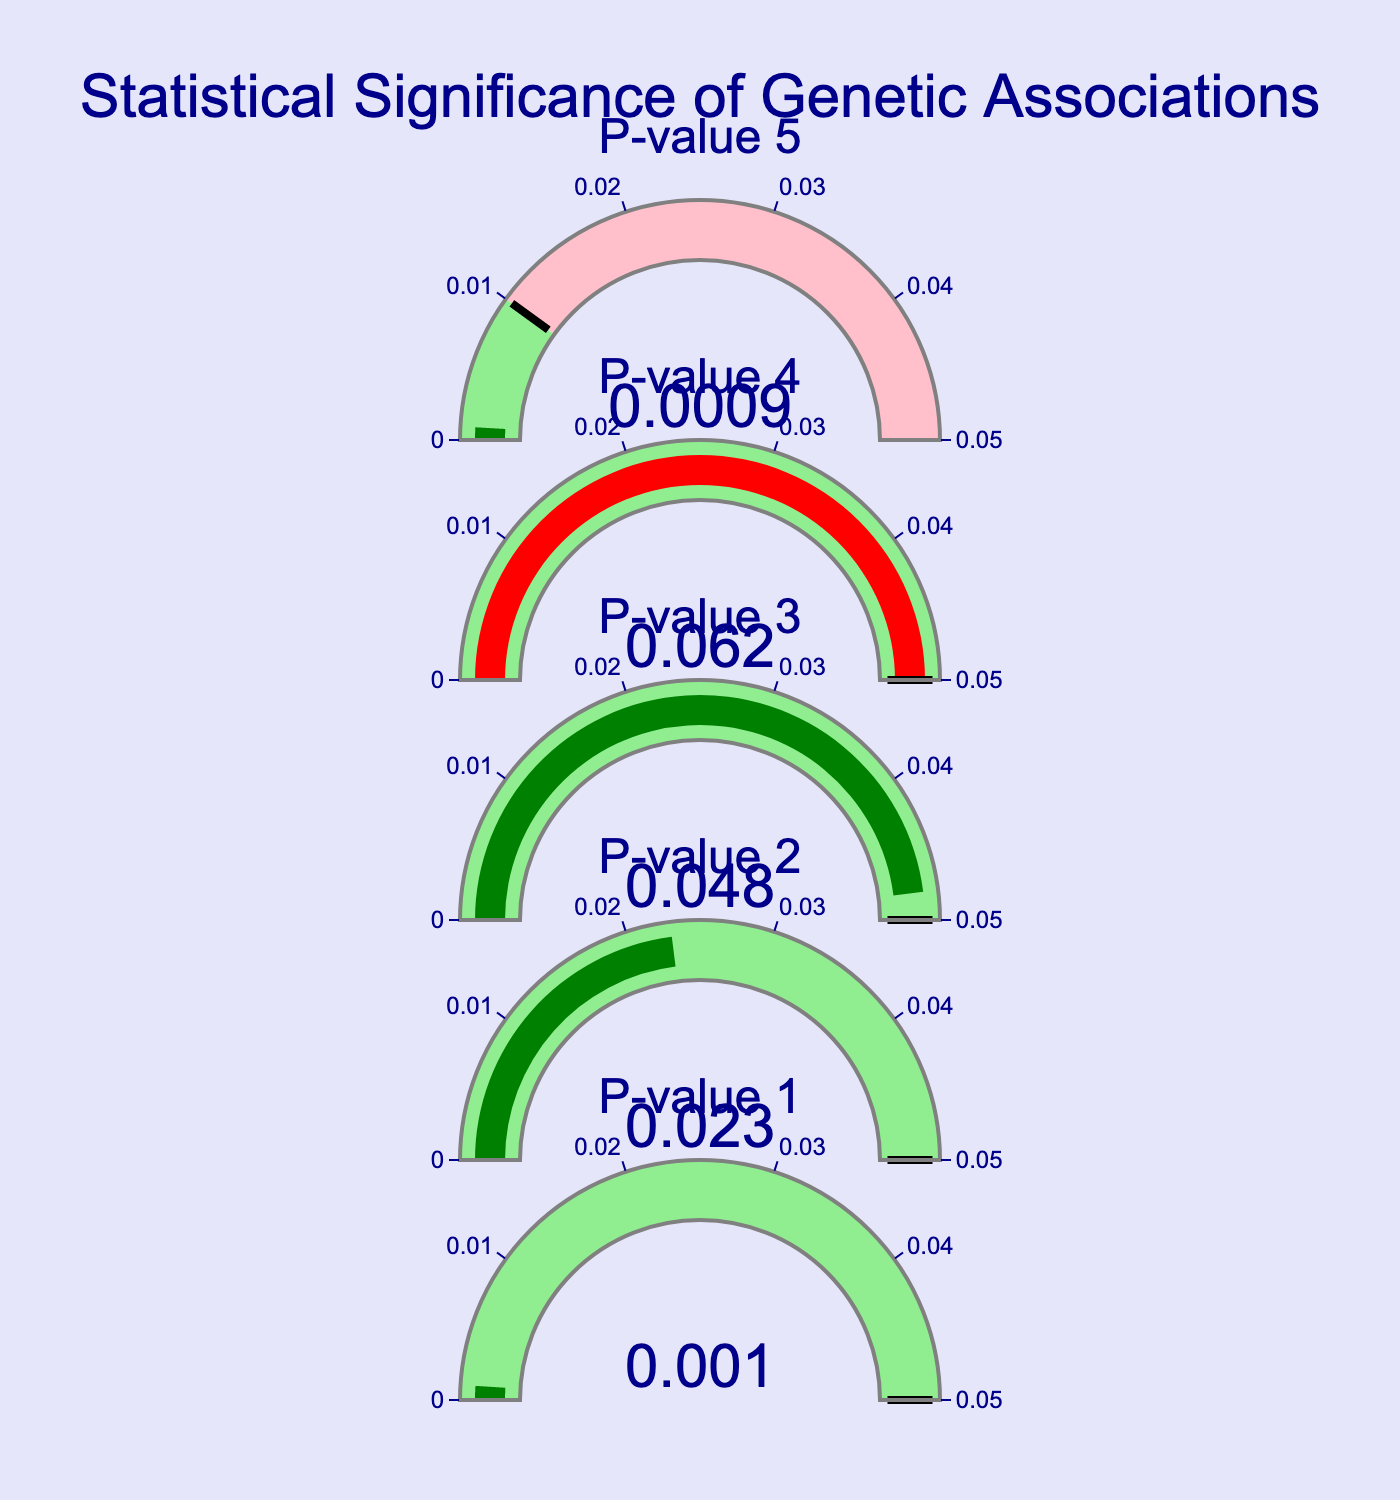What's the title of the figure? The title is located at the top center of the figure, displayed in a larger font size with dark blue color. By reading it, we find the title "Statistical Significance of Genetic Associations".
Answer: Statistical Significance of Genetic Associations How many gauge charts are there in the figure? By counting the individual gauges represented in the figure, we see there are 5 distinct ones.
Answer: 5 Which p-value is the smallest and what is its value? By examining each gauge, we identify the smallest p-value, which is 0.0009.
Answer: 0.0009 Which gauge has a p-value just above the significance level of 0.05? The gauge with a p-value of 0.062 is the one just above the significance level of 0.05.
Answer: 0.062 How many p-values are considered statistically significant (below the significance level)? We identify the gauges with green bars, indicating their p-values are below the significance level (0.05). Counts are: 0.001, 0.023, 0.048, and 0.0009, totaling to 4.
Answer: 4 What color is used to represent p-values above the significance level? Observing the figures, the p-values above the significance level are represented using a red color for the gauge bar.
Answer: Red Which p-value is closest to the significance threshold of 0.05? The p-value of 0.048 is the nearest to the threshold without exceeding it.
Answer: 0.048 How does the figure visually distinguish between statistically significant and non-significant p-values? The figure uses color to differentiate: green bars for significant p-values (below significance level) and red bars for non-significant p-values (above significance level). Also, significant regions are highlighted in light green, and non-significant regions in pink.
Answer: Color differentiation and highlighted regions 